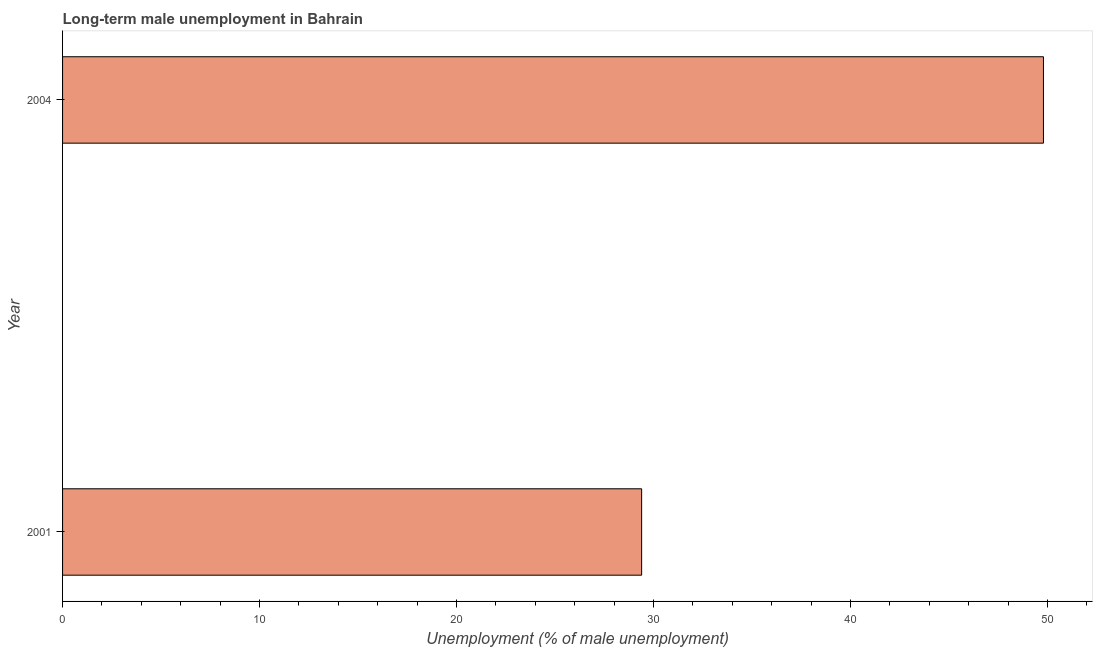What is the title of the graph?
Ensure brevity in your answer.  Long-term male unemployment in Bahrain. What is the label or title of the X-axis?
Offer a terse response. Unemployment (% of male unemployment). What is the long-term male unemployment in 2001?
Give a very brief answer. 29.4. Across all years, what is the maximum long-term male unemployment?
Make the answer very short. 49.8. Across all years, what is the minimum long-term male unemployment?
Keep it short and to the point. 29.4. What is the sum of the long-term male unemployment?
Your answer should be very brief. 79.2. What is the difference between the long-term male unemployment in 2001 and 2004?
Your response must be concise. -20.4. What is the average long-term male unemployment per year?
Provide a short and direct response. 39.6. What is the median long-term male unemployment?
Ensure brevity in your answer.  39.6. In how many years, is the long-term male unemployment greater than 14 %?
Your response must be concise. 2. Do a majority of the years between 2001 and 2004 (inclusive) have long-term male unemployment greater than 4 %?
Make the answer very short. Yes. What is the ratio of the long-term male unemployment in 2001 to that in 2004?
Offer a very short reply. 0.59. In how many years, is the long-term male unemployment greater than the average long-term male unemployment taken over all years?
Offer a very short reply. 1. How many bars are there?
Your response must be concise. 2. What is the difference between two consecutive major ticks on the X-axis?
Keep it short and to the point. 10. What is the Unemployment (% of male unemployment) in 2001?
Your answer should be compact. 29.4. What is the Unemployment (% of male unemployment) in 2004?
Offer a terse response. 49.8. What is the difference between the Unemployment (% of male unemployment) in 2001 and 2004?
Your answer should be very brief. -20.4. What is the ratio of the Unemployment (% of male unemployment) in 2001 to that in 2004?
Offer a very short reply. 0.59. 